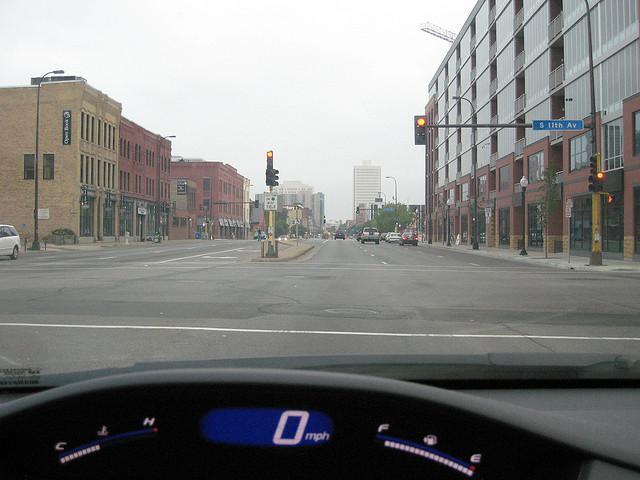How many people on the train are sitting next to a window that opens?
Give a very brief answer. 0. 